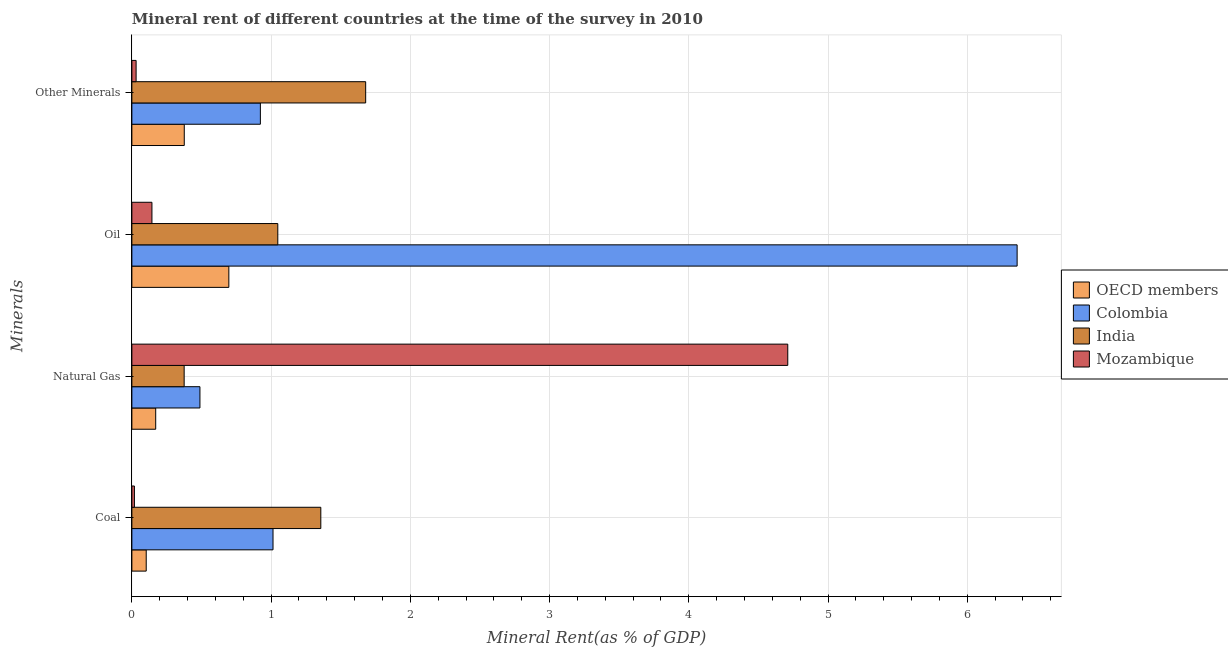How many different coloured bars are there?
Your answer should be very brief. 4. Are the number of bars on each tick of the Y-axis equal?
Your answer should be very brief. Yes. How many bars are there on the 3rd tick from the bottom?
Keep it short and to the point. 4. What is the label of the 3rd group of bars from the top?
Keep it short and to the point. Natural Gas. What is the  rent of other minerals in OECD members?
Keep it short and to the point. 0.38. Across all countries, what is the maximum oil rent?
Offer a very short reply. 6.36. Across all countries, what is the minimum natural gas rent?
Offer a very short reply. 0.17. In which country was the coal rent minimum?
Make the answer very short. Mozambique. What is the total  rent of other minerals in the graph?
Your answer should be very brief. 3.01. What is the difference between the oil rent in Mozambique and that in India?
Make the answer very short. -0.9. What is the difference between the  rent of other minerals in Colombia and the coal rent in OECD members?
Make the answer very short. 0.82. What is the average coal rent per country?
Provide a short and direct response. 0.62. What is the difference between the  rent of other minerals and oil rent in India?
Give a very brief answer. 0.63. In how many countries, is the oil rent greater than 0.2 %?
Ensure brevity in your answer.  3. What is the ratio of the coal rent in Mozambique to that in Colombia?
Ensure brevity in your answer.  0.02. Is the coal rent in OECD members less than that in Colombia?
Your answer should be very brief. Yes. What is the difference between the highest and the second highest  rent of other minerals?
Make the answer very short. 0.76. What is the difference between the highest and the lowest  rent of other minerals?
Your response must be concise. 1.65. In how many countries, is the oil rent greater than the average oil rent taken over all countries?
Your answer should be compact. 1. What does the 4th bar from the top in Oil represents?
Provide a short and direct response. OECD members. How many countries are there in the graph?
Provide a short and direct response. 4. What is the difference between two consecutive major ticks on the X-axis?
Offer a very short reply. 1. Are the values on the major ticks of X-axis written in scientific E-notation?
Your answer should be compact. No. Does the graph contain any zero values?
Your response must be concise. No. What is the title of the graph?
Your answer should be compact. Mineral rent of different countries at the time of the survey in 2010. What is the label or title of the X-axis?
Make the answer very short. Mineral Rent(as % of GDP). What is the label or title of the Y-axis?
Offer a terse response. Minerals. What is the Mineral Rent(as % of GDP) of OECD members in Coal?
Offer a terse response. 0.1. What is the Mineral Rent(as % of GDP) in Colombia in Coal?
Give a very brief answer. 1.01. What is the Mineral Rent(as % of GDP) in India in Coal?
Your response must be concise. 1.36. What is the Mineral Rent(as % of GDP) of Mozambique in Coal?
Offer a very short reply. 0.02. What is the Mineral Rent(as % of GDP) of OECD members in Natural Gas?
Ensure brevity in your answer.  0.17. What is the Mineral Rent(as % of GDP) in Colombia in Natural Gas?
Provide a succinct answer. 0.49. What is the Mineral Rent(as % of GDP) of India in Natural Gas?
Your answer should be very brief. 0.38. What is the Mineral Rent(as % of GDP) of Mozambique in Natural Gas?
Offer a terse response. 4.71. What is the Mineral Rent(as % of GDP) of OECD members in Oil?
Your response must be concise. 0.7. What is the Mineral Rent(as % of GDP) in Colombia in Oil?
Your response must be concise. 6.36. What is the Mineral Rent(as % of GDP) of India in Oil?
Offer a very short reply. 1.05. What is the Mineral Rent(as % of GDP) in Mozambique in Oil?
Your answer should be compact. 0.14. What is the Mineral Rent(as % of GDP) of OECD members in Other Minerals?
Your response must be concise. 0.38. What is the Mineral Rent(as % of GDP) of Colombia in Other Minerals?
Offer a very short reply. 0.92. What is the Mineral Rent(as % of GDP) of India in Other Minerals?
Give a very brief answer. 1.68. What is the Mineral Rent(as % of GDP) in Mozambique in Other Minerals?
Provide a succinct answer. 0.03. Across all Minerals, what is the maximum Mineral Rent(as % of GDP) in OECD members?
Give a very brief answer. 0.7. Across all Minerals, what is the maximum Mineral Rent(as % of GDP) in Colombia?
Offer a terse response. 6.36. Across all Minerals, what is the maximum Mineral Rent(as % of GDP) in India?
Ensure brevity in your answer.  1.68. Across all Minerals, what is the maximum Mineral Rent(as % of GDP) of Mozambique?
Give a very brief answer. 4.71. Across all Minerals, what is the minimum Mineral Rent(as % of GDP) in OECD members?
Give a very brief answer. 0.1. Across all Minerals, what is the minimum Mineral Rent(as % of GDP) of Colombia?
Your response must be concise. 0.49. Across all Minerals, what is the minimum Mineral Rent(as % of GDP) of India?
Ensure brevity in your answer.  0.38. Across all Minerals, what is the minimum Mineral Rent(as % of GDP) of Mozambique?
Offer a terse response. 0.02. What is the total Mineral Rent(as % of GDP) of OECD members in the graph?
Your response must be concise. 1.35. What is the total Mineral Rent(as % of GDP) of Colombia in the graph?
Ensure brevity in your answer.  8.78. What is the total Mineral Rent(as % of GDP) in India in the graph?
Give a very brief answer. 4.46. What is the total Mineral Rent(as % of GDP) of Mozambique in the graph?
Ensure brevity in your answer.  4.9. What is the difference between the Mineral Rent(as % of GDP) in OECD members in Coal and that in Natural Gas?
Provide a succinct answer. -0.07. What is the difference between the Mineral Rent(as % of GDP) in Colombia in Coal and that in Natural Gas?
Your answer should be very brief. 0.52. What is the difference between the Mineral Rent(as % of GDP) in India in Coal and that in Natural Gas?
Your answer should be very brief. 0.98. What is the difference between the Mineral Rent(as % of GDP) of Mozambique in Coal and that in Natural Gas?
Your response must be concise. -4.69. What is the difference between the Mineral Rent(as % of GDP) of OECD members in Coal and that in Oil?
Ensure brevity in your answer.  -0.59. What is the difference between the Mineral Rent(as % of GDP) in Colombia in Coal and that in Oil?
Your answer should be very brief. -5.34. What is the difference between the Mineral Rent(as % of GDP) in India in Coal and that in Oil?
Your answer should be very brief. 0.31. What is the difference between the Mineral Rent(as % of GDP) of Mozambique in Coal and that in Oil?
Ensure brevity in your answer.  -0.13. What is the difference between the Mineral Rent(as % of GDP) in OECD members in Coal and that in Other Minerals?
Keep it short and to the point. -0.27. What is the difference between the Mineral Rent(as % of GDP) of Colombia in Coal and that in Other Minerals?
Your answer should be compact. 0.09. What is the difference between the Mineral Rent(as % of GDP) of India in Coal and that in Other Minerals?
Your answer should be compact. -0.32. What is the difference between the Mineral Rent(as % of GDP) of Mozambique in Coal and that in Other Minerals?
Make the answer very short. -0.01. What is the difference between the Mineral Rent(as % of GDP) in OECD members in Natural Gas and that in Oil?
Provide a short and direct response. -0.53. What is the difference between the Mineral Rent(as % of GDP) of Colombia in Natural Gas and that in Oil?
Your response must be concise. -5.87. What is the difference between the Mineral Rent(as % of GDP) of India in Natural Gas and that in Oil?
Your answer should be very brief. -0.67. What is the difference between the Mineral Rent(as % of GDP) of Mozambique in Natural Gas and that in Oil?
Provide a succinct answer. 4.57. What is the difference between the Mineral Rent(as % of GDP) in OECD members in Natural Gas and that in Other Minerals?
Provide a short and direct response. -0.21. What is the difference between the Mineral Rent(as % of GDP) in Colombia in Natural Gas and that in Other Minerals?
Provide a short and direct response. -0.43. What is the difference between the Mineral Rent(as % of GDP) in India in Natural Gas and that in Other Minerals?
Provide a short and direct response. -1.3. What is the difference between the Mineral Rent(as % of GDP) of Mozambique in Natural Gas and that in Other Minerals?
Provide a short and direct response. 4.68. What is the difference between the Mineral Rent(as % of GDP) of OECD members in Oil and that in Other Minerals?
Your answer should be very brief. 0.32. What is the difference between the Mineral Rent(as % of GDP) of Colombia in Oil and that in Other Minerals?
Keep it short and to the point. 5.44. What is the difference between the Mineral Rent(as % of GDP) of India in Oil and that in Other Minerals?
Provide a short and direct response. -0.63. What is the difference between the Mineral Rent(as % of GDP) in Mozambique in Oil and that in Other Minerals?
Your response must be concise. 0.11. What is the difference between the Mineral Rent(as % of GDP) of OECD members in Coal and the Mineral Rent(as % of GDP) of Colombia in Natural Gas?
Ensure brevity in your answer.  -0.39. What is the difference between the Mineral Rent(as % of GDP) of OECD members in Coal and the Mineral Rent(as % of GDP) of India in Natural Gas?
Offer a terse response. -0.27. What is the difference between the Mineral Rent(as % of GDP) of OECD members in Coal and the Mineral Rent(as % of GDP) of Mozambique in Natural Gas?
Your answer should be very brief. -4.61. What is the difference between the Mineral Rent(as % of GDP) in Colombia in Coal and the Mineral Rent(as % of GDP) in India in Natural Gas?
Your answer should be very brief. 0.64. What is the difference between the Mineral Rent(as % of GDP) of Colombia in Coal and the Mineral Rent(as % of GDP) of Mozambique in Natural Gas?
Your response must be concise. -3.7. What is the difference between the Mineral Rent(as % of GDP) of India in Coal and the Mineral Rent(as % of GDP) of Mozambique in Natural Gas?
Offer a very short reply. -3.35. What is the difference between the Mineral Rent(as % of GDP) in OECD members in Coal and the Mineral Rent(as % of GDP) in Colombia in Oil?
Ensure brevity in your answer.  -6.25. What is the difference between the Mineral Rent(as % of GDP) in OECD members in Coal and the Mineral Rent(as % of GDP) in India in Oil?
Offer a terse response. -0.94. What is the difference between the Mineral Rent(as % of GDP) in OECD members in Coal and the Mineral Rent(as % of GDP) in Mozambique in Oil?
Provide a short and direct response. -0.04. What is the difference between the Mineral Rent(as % of GDP) of Colombia in Coal and the Mineral Rent(as % of GDP) of India in Oil?
Keep it short and to the point. -0.03. What is the difference between the Mineral Rent(as % of GDP) in Colombia in Coal and the Mineral Rent(as % of GDP) in Mozambique in Oil?
Give a very brief answer. 0.87. What is the difference between the Mineral Rent(as % of GDP) in India in Coal and the Mineral Rent(as % of GDP) in Mozambique in Oil?
Your answer should be very brief. 1.21. What is the difference between the Mineral Rent(as % of GDP) in OECD members in Coal and the Mineral Rent(as % of GDP) in Colombia in Other Minerals?
Ensure brevity in your answer.  -0.82. What is the difference between the Mineral Rent(as % of GDP) of OECD members in Coal and the Mineral Rent(as % of GDP) of India in Other Minerals?
Offer a very short reply. -1.58. What is the difference between the Mineral Rent(as % of GDP) in OECD members in Coal and the Mineral Rent(as % of GDP) in Mozambique in Other Minerals?
Offer a terse response. 0.07. What is the difference between the Mineral Rent(as % of GDP) in Colombia in Coal and the Mineral Rent(as % of GDP) in India in Other Minerals?
Keep it short and to the point. -0.67. What is the difference between the Mineral Rent(as % of GDP) of Colombia in Coal and the Mineral Rent(as % of GDP) of Mozambique in Other Minerals?
Your answer should be very brief. 0.98. What is the difference between the Mineral Rent(as % of GDP) of India in Coal and the Mineral Rent(as % of GDP) of Mozambique in Other Minerals?
Keep it short and to the point. 1.33. What is the difference between the Mineral Rent(as % of GDP) in OECD members in Natural Gas and the Mineral Rent(as % of GDP) in Colombia in Oil?
Provide a succinct answer. -6.19. What is the difference between the Mineral Rent(as % of GDP) in OECD members in Natural Gas and the Mineral Rent(as % of GDP) in India in Oil?
Make the answer very short. -0.88. What is the difference between the Mineral Rent(as % of GDP) in OECD members in Natural Gas and the Mineral Rent(as % of GDP) in Mozambique in Oil?
Your answer should be very brief. 0.03. What is the difference between the Mineral Rent(as % of GDP) in Colombia in Natural Gas and the Mineral Rent(as % of GDP) in India in Oil?
Your answer should be compact. -0.56. What is the difference between the Mineral Rent(as % of GDP) of Colombia in Natural Gas and the Mineral Rent(as % of GDP) of Mozambique in Oil?
Make the answer very short. 0.34. What is the difference between the Mineral Rent(as % of GDP) in India in Natural Gas and the Mineral Rent(as % of GDP) in Mozambique in Oil?
Offer a very short reply. 0.23. What is the difference between the Mineral Rent(as % of GDP) of OECD members in Natural Gas and the Mineral Rent(as % of GDP) of Colombia in Other Minerals?
Your response must be concise. -0.75. What is the difference between the Mineral Rent(as % of GDP) in OECD members in Natural Gas and the Mineral Rent(as % of GDP) in India in Other Minerals?
Make the answer very short. -1.51. What is the difference between the Mineral Rent(as % of GDP) in OECD members in Natural Gas and the Mineral Rent(as % of GDP) in Mozambique in Other Minerals?
Your response must be concise. 0.14. What is the difference between the Mineral Rent(as % of GDP) of Colombia in Natural Gas and the Mineral Rent(as % of GDP) of India in Other Minerals?
Make the answer very short. -1.19. What is the difference between the Mineral Rent(as % of GDP) in Colombia in Natural Gas and the Mineral Rent(as % of GDP) in Mozambique in Other Minerals?
Provide a short and direct response. 0.46. What is the difference between the Mineral Rent(as % of GDP) of India in Natural Gas and the Mineral Rent(as % of GDP) of Mozambique in Other Minerals?
Ensure brevity in your answer.  0.35. What is the difference between the Mineral Rent(as % of GDP) of OECD members in Oil and the Mineral Rent(as % of GDP) of Colombia in Other Minerals?
Provide a short and direct response. -0.23. What is the difference between the Mineral Rent(as % of GDP) in OECD members in Oil and the Mineral Rent(as % of GDP) in India in Other Minerals?
Provide a succinct answer. -0.98. What is the difference between the Mineral Rent(as % of GDP) of OECD members in Oil and the Mineral Rent(as % of GDP) of Mozambique in Other Minerals?
Make the answer very short. 0.67. What is the difference between the Mineral Rent(as % of GDP) of Colombia in Oil and the Mineral Rent(as % of GDP) of India in Other Minerals?
Make the answer very short. 4.68. What is the difference between the Mineral Rent(as % of GDP) in Colombia in Oil and the Mineral Rent(as % of GDP) in Mozambique in Other Minerals?
Make the answer very short. 6.33. What is the difference between the Mineral Rent(as % of GDP) in India in Oil and the Mineral Rent(as % of GDP) in Mozambique in Other Minerals?
Offer a terse response. 1.02. What is the average Mineral Rent(as % of GDP) of OECD members per Minerals?
Your answer should be compact. 0.34. What is the average Mineral Rent(as % of GDP) in Colombia per Minerals?
Provide a short and direct response. 2.2. What is the average Mineral Rent(as % of GDP) in India per Minerals?
Your answer should be compact. 1.11. What is the average Mineral Rent(as % of GDP) in Mozambique per Minerals?
Your response must be concise. 1.23. What is the difference between the Mineral Rent(as % of GDP) in OECD members and Mineral Rent(as % of GDP) in Colombia in Coal?
Your answer should be compact. -0.91. What is the difference between the Mineral Rent(as % of GDP) in OECD members and Mineral Rent(as % of GDP) in India in Coal?
Ensure brevity in your answer.  -1.25. What is the difference between the Mineral Rent(as % of GDP) in OECD members and Mineral Rent(as % of GDP) in Mozambique in Coal?
Your response must be concise. 0.08. What is the difference between the Mineral Rent(as % of GDP) in Colombia and Mineral Rent(as % of GDP) in India in Coal?
Provide a short and direct response. -0.34. What is the difference between the Mineral Rent(as % of GDP) in India and Mineral Rent(as % of GDP) in Mozambique in Coal?
Offer a very short reply. 1.34. What is the difference between the Mineral Rent(as % of GDP) of OECD members and Mineral Rent(as % of GDP) of Colombia in Natural Gas?
Offer a terse response. -0.32. What is the difference between the Mineral Rent(as % of GDP) in OECD members and Mineral Rent(as % of GDP) in India in Natural Gas?
Provide a short and direct response. -0.2. What is the difference between the Mineral Rent(as % of GDP) of OECD members and Mineral Rent(as % of GDP) of Mozambique in Natural Gas?
Make the answer very short. -4.54. What is the difference between the Mineral Rent(as % of GDP) in Colombia and Mineral Rent(as % of GDP) in India in Natural Gas?
Keep it short and to the point. 0.11. What is the difference between the Mineral Rent(as % of GDP) in Colombia and Mineral Rent(as % of GDP) in Mozambique in Natural Gas?
Your answer should be very brief. -4.22. What is the difference between the Mineral Rent(as % of GDP) in India and Mineral Rent(as % of GDP) in Mozambique in Natural Gas?
Your response must be concise. -4.34. What is the difference between the Mineral Rent(as % of GDP) in OECD members and Mineral Rent(as % of GDP) in Colombia in Oil?
Provide a short and direct response. -5.66. What is the difference between the Mineral Rent(as % of GDP) in OECD members and Mineral Rent(as % of GDP) in India in Oil?
Provide a succinct answer. -0.35. What is the difference between the Mineral Rent(as % of GDP) in OECD members and Mineral Rent(as % of GDP) in Mozambique in Oil?
Your answer should be compact. 0.55. What is the difference between the Mineral Rent(as % of GDP) in Colombia and Mineral Rent(as % of GDP) in India in Oil?
Offer a very short reply. 5.31. What is the difference between the Mineral Rent(as % of GDP) of Colombia and Mineral Rent(as % of GDP) of Mozambique in Oil?
Offer a very short reply. 6.21. What is the difference between the Mineral Rent(as % of GDP) in India and Mineral Rent(as % of GDP) in Mozambique in Oil?
Give a very brief answer. 0.9. What is the difference between the Mineral Rent(as % of GDP) of OECD members and Mineral Rent(as % of GDP) of Colombia in Other Minerals?
Your response must be concise. -0.55. What is the difference between the Mineral Rent(as % of GDP) of OECD members and Mineral Rent(as % of GDP) of India in Other Minerals?
Your answer should be very brief. -1.3. What is the difference between the Mineral Rent(as % of GDP) in OECD members and Mineral Rent(as % of GDP) in Mozambique in Other Minerals?
Offer a terse response. 0.35. What is the difference between the Mineral Rent(as % of GDP) of Colombia and Mineral Rent(as % of GDP) of India in Other Minerals?
Provide a succinct answer. -0.76. What is the difference between the Mineral Rent(as % of GDP) in Colombia and Mineral Rent(as % of GDP) in Mozambique in Other Minerals?
Your answer should be compact. 0.89. What is the difference between the Mineral Rent(as % of GDP) in India and Mineral Rent(as % of GDP) in Mozambique in Other Minerals?
Offer a terse response. 1.65. What is the ratio of the Mineral Rent(as % of GDP) in OECD members in Coal to that in Natural Gas?
Provide a short and direct response. 0.6. What is the ratio of the Mineral Rent(as % of GDP) of Colombia in Coal to that in Natural Gas?
Offer a terse response. 2.07. What is the ratio of the Mineral Rent(as % of GDP) in India in Coal to that in Natural Gas?
Your response must be concise. 3.61. What is the ratio of the Mineral Rent(as % of GDP) in Mozambique in Coal to that in Natural Gas?
Ensure brevity in your answer.  0. What is the ratio of the Mineral Rent(as % of GDP) of OECD members in Coal to that in Oil?
Ensure brevity in your answer.  0.15. What is the ratio of the Mineral Rent(as % of GDP) in Colombia in Coal to that in Oil?
Provide a short and direct response. 0.16. What is the ratio of the Mineral Rent(as % of GDP) of India in Coal to that in Oil?
Offer a terse response. 1.29. What is the ratio of the Mineral Rent(as % of GDP) in Mozambique in Coal to that in Oil?
Provide a succinct answer. 0.13. What is the ratio of the Mineral Rent(as % of GDP) of OECD members in Coal to that in Other Minerals?
Offer a terse response. 0.27. What is the ratio of the Mineral Rent(as % of GDP) of Colombia in Coal to that in Other Minerals?
Your answer should be very brief. 1.1. What is the ratio of the Mineral Rent(as % of GDP) of India in Coal to that in Other Minerals?
Your answer should be very brief. 0.81. What is the ratio of the Mineral Rent(as % of GDP) of Mozambique in Coal to that in Other Minerals?
Offer a terse response. 0.6. What is the ratio of the Mineral Rent(as % of GDP) of OECD members in Natural Gas to that in Oil?
Your answer should be compact. 0.25. What is the ratio of the Mineral Rent(as % of GDP) of Colombia in Natural Gas to that in Oil?
Ensure brevity in your answer.  0.08. What is the ratio of the Mineral Rent(as % of GDP) of India in Natural Gas to that in Oil?
Make the answer very short. 0.36. What is the ratio of the Mineral Rent(as % of GDP) of Mozambique in Natural Gas to that in Oil?
Keep it short and to the point. 32.7. What is the ratio of the Mineral Rent(as % of GDP) in OECD members in Natural Gas to that in Other Minerals?
Provide a short and direct response. 0.45. What is the ratio of the Mineral Rent(as % of GDP) in Colombia in Natural Gas to that in Other Minerals?
Provide a short and direct response. 0.53. What is the ratio of the Mineral Rent(as % of GDP) of India in Natural Gas to that in Other Minerals?
Ensure brevity in your answer.  0.22. What is the ratio of the Mineral Rent(as % of GDP) in Mozambique in Natural Gas to that in Other Minerals?
Ensure brevity in your answer.  154.76. What is the ratio of the Mineral Rent(as % of GDP) of OECD members in Oil to that in Other Minerals?
Ensure brevity in your answer.  1.85. What is the ratio of the Mineral Rent(as % of GDP) of Colombia in Oil to that in Other Minerals?
Make the answer very short. 6.89. What is the ratio of the Mineral Rent(as % of GDP) of India in Oil to that in Other Minerals?
Provide a succinct answer. 0.62. What is the ratio of the Mineral Rent(as % of GDP) in Mozambique in Oil to that in Other Minerals?
Your answer should be very brief. 4.73. What is the difference between the highest and the second highest Mineral Rent(as % of GDP) of OECD members?
Ensure brevity in your answer.  0.32. What is the difference between the highest and the second highest Mineral Rent(as % of GDP) of Colombia?
Keep it short and to the point. 5.34. What is the difference between the highest and the second highest Mineral Rent(as % of GDP) in India?
Your answer should be very brief. 0.32. What is the difference between the highest and the second highest Mineral Rent(as % of GDP) in Mozambique?
Your answer should be compact. 4.57. What is the difference between the highest and the lowest Mineral Rent(as % of GDP) of OECD members?
Your answer should be compact. 0.59. What is the difference between the highest and the lowest Mineral Rent(as % of GDP) of Colombia?
Give a very brief answer. 5.87. What is the difference between the highest and the lowest Mineral Rent(as % of GDP) in India?
Your response must be concise. 1.3. What is the difference between the highest and the lowest Mineral Rent(as % of GDP) of Mozambique?
Your answer should be very brief. 4.69. 